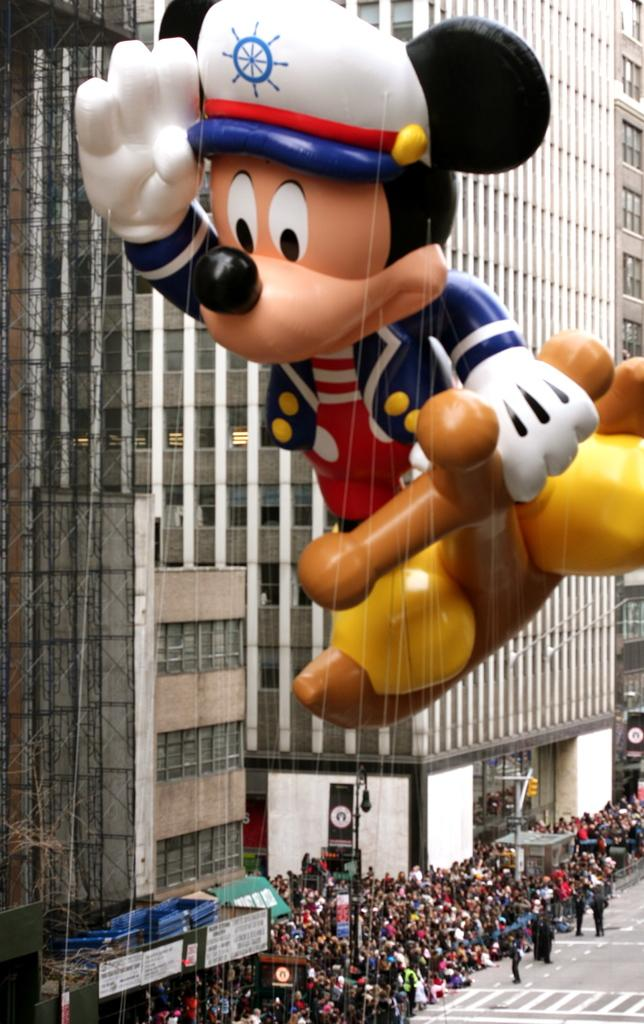What is the main subject of the picture? The main subject of the picture is a Mickey Mouse balloon. What can be seen in the background of the picture? There are buildings visible in the picture. What are the people in the picture doing? There is a group of people standing on the ground. What else can be seen in the picture besides the balloon and buildings? There are poles and other unspecified objects in the picture. What type of silk fabric is draped over the love seat in the picture? There is no love seat or silk fabric present in the image; it features a Mickey Mouse balloon and a group of people standing on the ground. 